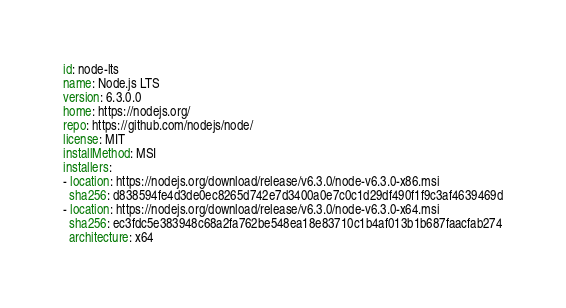Convert code to text. <code><loc_0><loc_0><loc_500><loc_500><_YAML_>id: node-lts
name: Node.js LTS
version: 6.3.0.0
home: https://nodejs.org/
repo: https://github.com/nodejs/node/
license: MIT
installMethod: MSI
installers:
- location: https://nodejs.org/download/release/v6.3.0/node-v6.3.0-x86.msi
  sha256: d838594fe4d3de0ec8265d742e7d3400a0e7c0c1d29df490f1f9c3af4639469d
- location: https://nodejs.org/download/release/v6.3.0/node-v6.3.0-x64.msi
  sha256: ec3fdc5e383948c68a2fa762be548ea18e83710c1b4af013b1b687faacfab274
  architecture: x64
</code> 